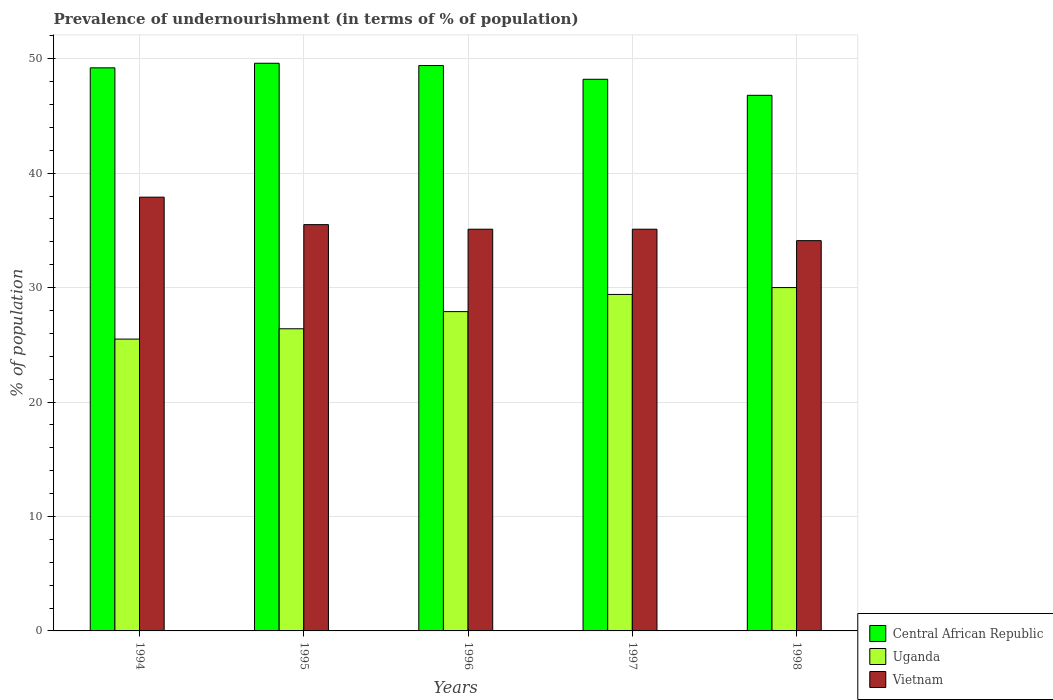How many different coloured bars are there?
Make the answer very short. 3. How many groups of bars are there?
Your answer should be very brief. 5. Are the number of bars per tick equal to the number of legend labels?
Keep it short and to the point. Yes. Are the number of bars on each tick of the X-axis equal?
Offer a very short reply. Yes. How many bars are there on the 1st tick from the right?
Give a very brief answer. 3. What is the label of the 4th group of bars from the left?
Give a very brief answer. 1997. In how many cases, is the number of bars for a given year not equal to the number of legend labels?
Ensure brevity in your answer.  0. What is the percentage of undernourished population in Vietnam in 1996?
Ensure brevity in your answer.  35.1. In which year was the percentage of undernourished population in Uganda maximum?
Ensure brevity in your answer.  1998. What is the total percentage of undernourished population in Vietnam in the graph?
Provide a short and direct response. 177.7. What is the difference between the percentage of undernourished population in Central African Republic in 1994 and that in 1995?
Make the answer very short. -0.4. What is the difference between the percentage of undernourished population in Uganda in 1998 and the percentage of undernourished population in Central African Republic in 1995?
Give a very brief answer. -19.6. What is the average percentage of undernourished population in Vietnam per year?
Offer a terse response. 35.54. In the year 1998, what is the difference between the percentage of undernourished population in Vietnam and percentage of undernourished population in Central African Republic?
Offer a very short reply. -12.7. What is the ratio of the percentage of undernourished population in Vietnam in 1995 to that in 1997?
Offer a very short reply. 1.01. What is the difference between the highest and the second highest percentage of undernourished population in Vietnam?
Offer a terse response. 2.4. What is the difference between the highest and the lowest percentage of undernourished population in Central African Republic?
Keep it short and to the point. 2.8. In how many years, is the percentage of undernourished population in Uganda greater than the average percentage of undernourished population in Uganda taken over all years?
Your response must be concise. 3. Is the sum of the percentage of undernourished population in Vietnam in 1994 and 1997 greater than the maximum percentage of undernourished population in Uganda across all years?
Offer a very short reply. Yes. What does the 2nd bar from the left in 1995 represents?
Your answer should be very brief. Uganda. What does the 3rd bar from the right in 1994 represents?
Your answer should be very brief. Central African Republic. Is it the case that in every year, the sum of the percentage of undernourished population in Uganda and percentage of undernourished population in Vietnam is greater than the percentage of undernourished population in Central African Republic?
Give a very brief answer. Yes. How many bars are there?
Your answer should be very brief. 15. Are all the bars in the graph horizontal?
Offer a terse response. No. Are the values on the major ticks of Y-axis written in scientific E-notation?
Offer a terse response. No. Where does the legend appear in the graph?
Provide a succinct answer. Bottom right. How many legend labels are there?
Make the answer very short. 3. How are the legend labels stacked?
Ensure brevity in your answer.  Vertical. What is the title of the graph?
Keep it short and to the point. Prevalence of undernourishment (in terms of % of population). Does "Burkina Faso" appear as one of the legend labels in the graph?
Offer a terse response. No. What is the label or title of the X-axis?
Ensure brevity in your answer.  Years. What is the label or title of the Y-axis?
Give a very brief answer. % of population. What is the % of population in Central African Republic in 1994?
Your answer should be compact. 49.2. What is the % of population of Vietnam in 1994?
Your answer should be compact. 37.9. What is the % of population of Central African Republic in 1995?
Give a very brief answer. 49.6. What is the % of population of Uganda in 1995?
Provide a short and direct response. 26.4. What is the % of population in Vietnam in 1995?
Ensure brevity in your answer.  35.5. What is the % of population of Central African Republic in 1996?
Give a very brief answer. 49.4. What is the % of population in Uganda in 1996?
Ensure brevity in your answer.  27.9. What is the % of population in Vietnam in 1996?
Offer a terse response. 35.1. What is the % of population in Central African Republic in 1997?
Your answer should be compact. 48.2. What is the % of population of Uganda in 1997?
Provide a succinct answer. 29.4. What is the % of population in Vietnam in 1997?
Offer a very short reply. 35.1. What is the % of population of Central African Republic in 1998?
Make the answer very short. 46.8. What is the % of population in Vietnam in 1998?
Your answer should be very brief. 34.1. Across all years, what is the maximum % of population of Central African Republic?
Ensure brevity in your answer.  49.6. Across all years, what is the maximum % of population in Uganda?
Your answer should be very brief. 30. Across all years, what is the maximum % of population of Vietnam?
Give a very brief answer. 37.9. Across all years, what is the minimum % of population of Central African Republic?
Your answer should be very brief. 46.8. Across all years, what is the minimum % of population of Vietnam?
Your answer should be very brief. 34.1. What is the total % of population in Central African Republic in the graph?
Provide a short and direct response. 243.2. What is the total % of population of Uganda in the graph?
Keep it short and to the point. 139.2. What is the total % of population of Vietnam in the graph?
Your answer should be very brief. 177.7. What is the difference between the % of population in Central African Republic in 1994 and that in 1997?
Give a very brief answer. 1. What is the difference between the % of population in Uganda in 1994 and that in 1997?
Offer a very short reply. -3.9. What is the difference between the % of population in Central African Republic in 1994 and that in 1998?
Your answer should be compact. 2.4. What is the difference between the % of population in Uganda in 1994 and that in 1998?
Provide a succinct answer. -4.5. What is the difference between the % of population in Vietnam in 1994 and that in 1998?
Provide a short and direct response. 3.8. What is the difference between the % of population of Vietnam in 1995 and that in 1997?
Offer a terse response. 0.4. What is the difference between the % of population of Central African Republic in 1995 and that in 1998?
Your answer should be compact. 2.8. What is the difference between the % of population in Uganda in 1996 and that in 1997?
Your answer should be very brief. -1.5. What is the difference between the % of population of Vietnam in 1996 and that in 1997?
Offer a terse response. 0. What is the difference between the % of population of Central African Republic in 1996 and that in 1998?
Make the answer very short. 2.6. What is the difference between the % of population in Central African Republic in 1997 and that in 1998?
Offer a terse response. 1.4. What is the difference between the % of population in Central African Republic in 1994 and the % of population in Uganda in 1995?
Provide a succinct answer. 22.8. What is the difference between the % of population of Central African Republic in 1994 and the % of population of Vietnam in 1995?
Offer a terse response. 13.7. What is the difference between the % of population in Uganda in 1994 and the % of population in Vietnam in 1995?
Provide a succinct answer. -10. What is the difference between the % of population of Central African Republic in 1994 and the % of population of Uganda in 1996?
Provide a short and direct response. 21.3. What is the difference between the % of population of Central African Republic in 1994 and the % of population of Vietnam in 1996?
Provide a short and direct response. 14.1. What is the difference between the % of population in Central African Republic in 1994 and the % of population in Uganda in 1997?
Provide a short and direct response. 19.8. What is the difference between the % of population of Central African Republic in 1994 and the % of population of Uganda in 1998?
Make the answer very short. 19.2. What is the difference between the % of population of Central African Republic in 1994 and the % of population of Vietnam in 1998?
Ensure brevity in your answer.  15.1. What is the difference between the % of population of Uganda in 1994 and the % of population of Vietnam in 1998?
Keep it short and to the point. -8.6. What is the difference between the % of population of Central African Republic in 1995 and the % of population of Uganda in 1996?
Offer a very short reply. 21.7. What is the difference between the % of population of Central African Republic in 1995 and the % of population of Vietnam in 1996?
Your response must be concise. 14.5. What is the difference between the % of population in Central African Republic in 1995 and the % of population in Uganda in 1997?
Offer a very short reply. 20.2. What is the difference between the % of population in Central African Republic in 1995 and the % of population in Uganda in 1998?
Your answer should be very brief. 19.6. What is the difference between the % of population in Uganda in 1995 and the % of population in Vietnam in 1998?
Make the answer very short. -7.7. What is the difference between the % of population of Central African Republic in 1996 and the % of population of Vietnam in 1997?
Keep it short and to the point. 14.3. What is the difference between the % of population of Central African Republic in 1996 and the % of population of Vietnam in 1998?
Offer a terse response. 15.3. What is the difference between the % of population of Uganda in 1996 and the % of population of Vietnam in 1998?
Offer a terse response. -6.2. What is the difference between the % of population of Central African Republic in 1997 and the % of population of Vietnam in 1998?
Your answer should be very brief. 14.1. What is the average % of population in Central African Republic per year?
Offer a very short reply. 48.64. What is the average % of population in Uganda per year?
Your answer should be very brief. 27.84. What is the average % of population in Vietnam per year?
Provide a short and direct response. 35.54. In the year 1994, what is the difference between the % of population of Central African Republic and % of population of Uganda?
Your answer should be very brief. 23.7. In the year 1995, what is the difference between the % of population of Central African Republic and % of population of Uganda?
Offer a terse response. 23.2. In the year 1995, what is the difference between the % of population of Central African Republic and % of population of Vietnam?
Provide a short and direct response. 14.1. In the year 1996, what is the difference between the % of population of Central African Republic and % of population of Uganda?
Give a very brief answer. 21.5. In the year 1996, what is the difference between the % of population in Central African Republic and % of population in Vietnam?
Your answer should be compact. 14.3. In the year 1997, what is the difference between the % of population in Central African Republic and % of population in Uganda?
Provide a short and direct response. 18.8. In the year 1997, what is the difference between the % of population in Central African Republic and % of population in Vietnam?
Make the answer very short. 13.1. In the year 1997, what is the difference between the % of population in Uganda and % of population in Vietnam?
Make the answer very short. -5.7. In the year 1998, what is the difference between the % of population in Central African Republic and % of population in Vietnam?
Your response must be concise. 12.7. What is the ratio of the % of population in Central African Republic in 1994 to that in 1995?
Provide a succinct answer. 0.99. What is the ratio of the % of population in Uganda in 1994 to that in 1995?
Provide a short and direct response. 0.97. What is the ratio of the % of population of Vietnam in 1994 to that in 1995?
Offer a terse response. 1.07. What is the ratio of the % of population in Central African Republic in 1994 to that in 1996?
Give a very brief answer. 1. What is the ratio of the % of population in Uganda in 1994 to that in 1996?
Your response must be concise. 0.91. What is the ratio of the % of population in Vietnam in 1994 to that in 1996?
Offer a terse response. 1.08. What is the ratio of the % of population in Central African Republic in 1994 to that in 1997?
Provide a succinct answer. 1.02. What is the ratio of the % of population of Uganda in 1994 to that in 1997?
Ensure brevity in your answer.  0.87. What is the ratio of the % of population in Vietnam in 1994 to that in 1997?
Offer a terse response. 1.08. What is the ratio of the % of population of Central African Republic in 1994 to that in 1998?
Give a very brief answer. 1.05. What is the ratio of the % of population of Vietnam in 1994 to that in 1998?
Offer a terse response. 1.11. What is the ratio of the % of population in Central African Republic in 1995 to that in 1996?
Your response must be concise. 1. What is the ratio of the % of population of Uganda in 1995 to that in 1996?
Ensure brevity in your answer.  0.95. What is the ratio of the % of population of Vietnam in 1995 to that in 1996?
Offer a terse response. 1.01. What is the ratio of the % of population of Central African Republic in 1995 to that in 1997?
Keep it short and to the point. 1.03. What is the ratio of the % of population of Uganda in 1995 to that in 1997?
Your answer should be very brief. 0.9. What is the ratio of the % of population in Vietnam in 1995 to that in 1997?
Make the answer very short. 1.01. What is the ratio of the % of population in Central African Republic in 1995 to that in 1998?
Ensure brevity in your answer.  1.06. What is the ratio of the % of population in Uganda in 1995 to that in 1998?
Provide a succinct answer. 0.88. What is the ratio of the % of population of Vietnam in 1995 to that in 1998?
Keep it short and to the point. 1.04. What is the ratio of the % of population in Central African Republic in 1996 to that in 1997?
Make the answer very short. 1.02. What is the ratio of the % of population in Uganda in 1996 to that in 1997?
Make the answer very short. 0.95. What is the ratio of the % of population in Central African Republic in 1996 to that in 1998?
Your answer should be compact. 1.06. What is the ratio of the % of population in Vietnam in 1996 to that in 1998?
Your response must be concise. 1.03. What is the ratio of the % of population in Central African Republic in 1997 to that in 1998?
Provide a short and direct response. 1.03. What is the ratio of the % of population of Vietnam in 1997 to that in 1998?
Offer a very short reply. 1.03. What is the difference between the highest and the second highest % of population in Central African Republic?
Offer a very short reply. 0.2. What is the difference between the highest and the second highest % of population in Uganda?
Make the answer very short. 0.6. 